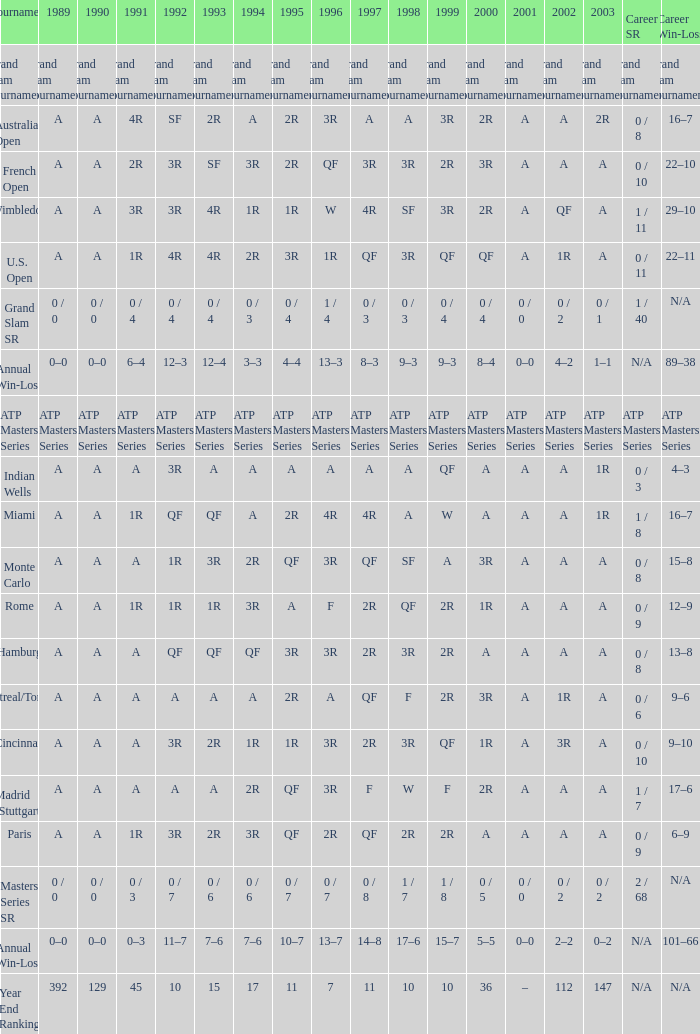What was the career SR with a value of A in 1980 and F in 1997? 1 / 7. 